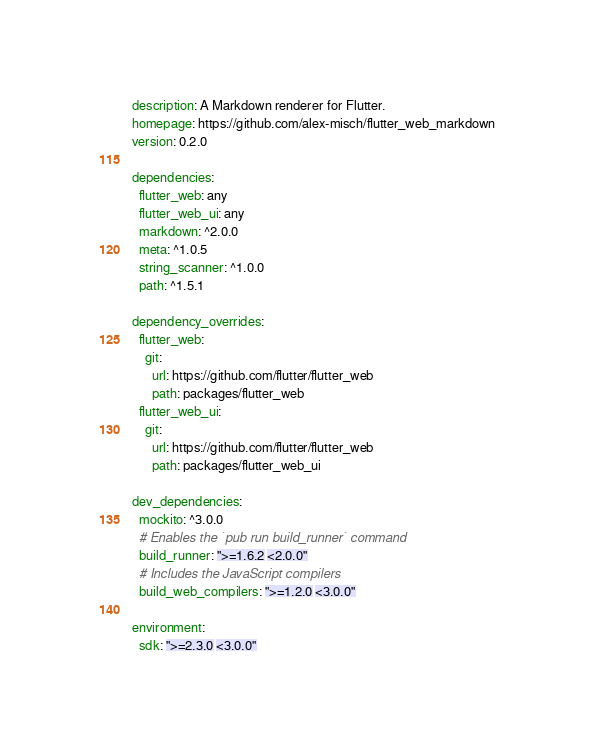<code> <loc_0><loc_0><loc_500><loc_500><_YAML_>description: A Markdown renderer for Flutter.
homepage: https://github.com/alex-misch/flutter_web_markdown
version: 0.2.0

dependencies:
  flutter_web: any
  flutter_web_ui: any
  markdown: ^2.0.0
  meta: ^1.0.5
  string_scanner: ^1.0.0
  path: ^1.5.1

dependency_overrides:
  flutter_web:
    git:
      url: https://github.com/flutter/flutter_web
      path: packages/flutter_web
  flutter_web_ui:
    git:
      url: https://github.com/flutter/flutter_web
      path: packages/flutter_web_ui

dev_dependencies:
  mockito: ^3.0.0
  # Enables the `pub run build_runner` command
  build_runner: ">=1.6.2 <2.0.0"
  # Includes the JavaScript compilers
  build_web_compilers: ">=1.2.0 <3.0.0"

environment:
  sdk: ">=2.3.0 <3.0.0"
</code> 